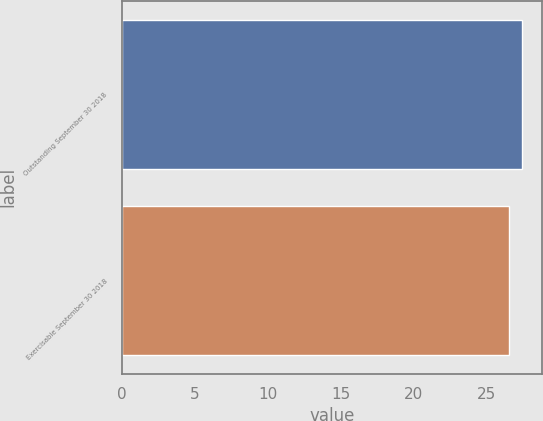Convert chart to OTSL. <chart><loc_0><loc_0><loc_500><loc_500><bar_chart><fcel>Outstanding September 30 2018<fcel>Exercisable September 30 2018<nl><fcel>27.39<fcel>26.52<nl></chart> 